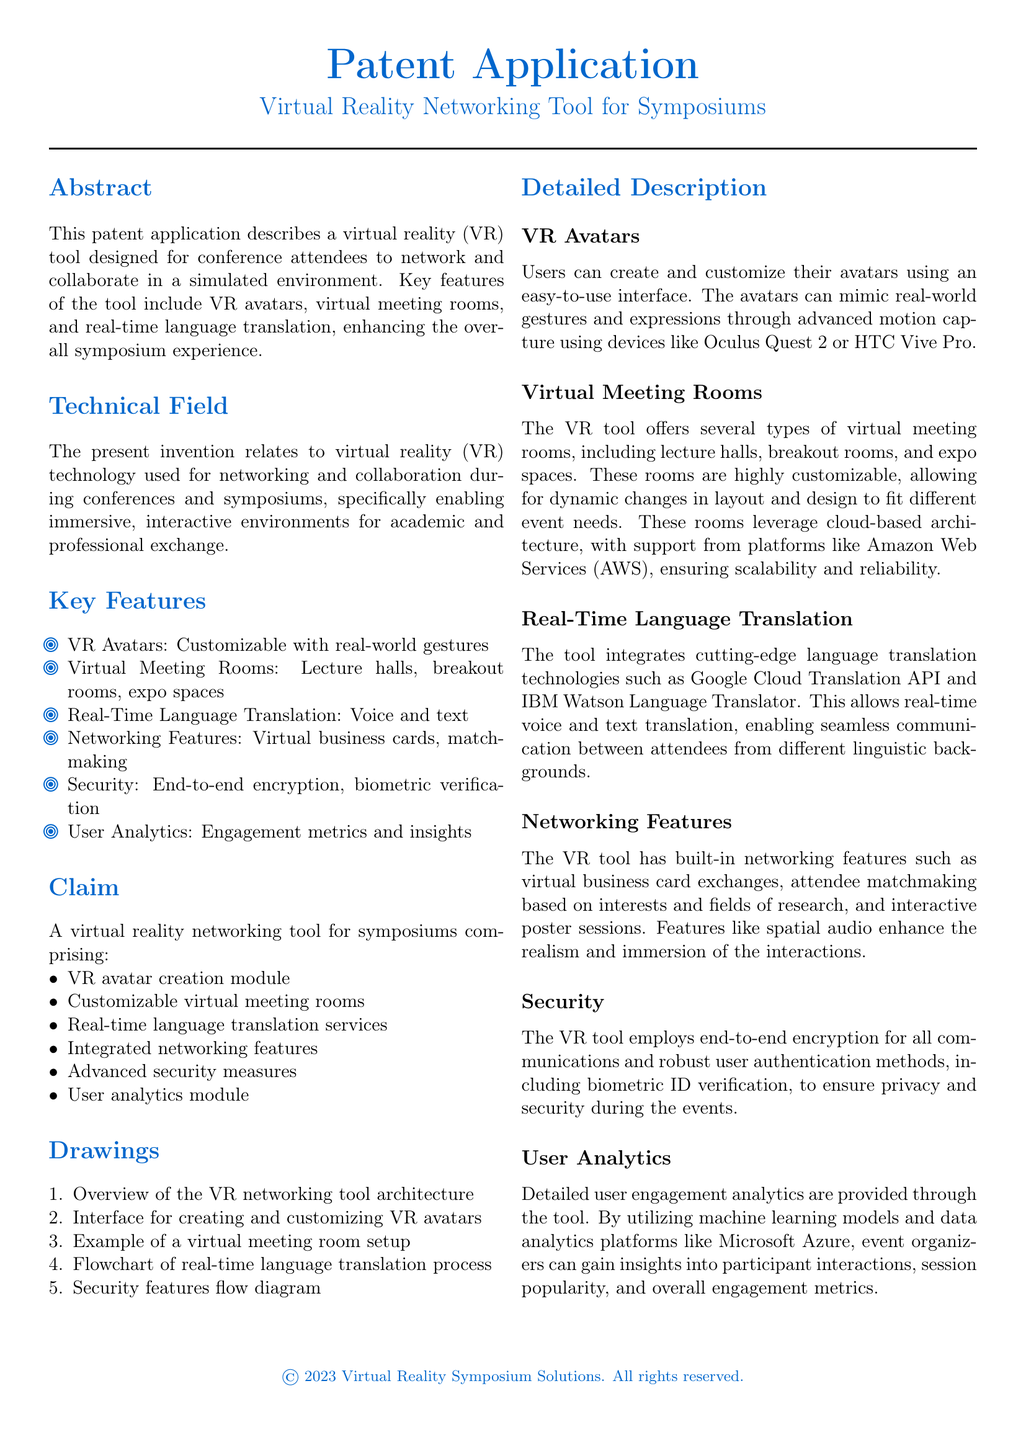What is the title of the patent application? The title is specifically mentioned in the heading of the document.
Answer: Virtual Reality Networking Tool for Symposiums What are the main customizable features of the VR tool? The document lists specific features under the Key Features section.
Answer: VR Avatars, Virtual Meeting Rooms, Real-Time Language Translation How many types of virtual meeting rooms are mentioned? The detailed description provides specific types listed under Virtual Meeting Rooms.
Answer: Three Which technological services are integrated for real-time language translation? The document references specific technologies in the Real-Time Language Translation section.
Answer: Google Cloud Translation API and IBM Watson Language Translator What advanced security method is mentioned in the document? The security section mentions specific verification methods.
Answer: Biometric verification What user engagement analytics platform is mentioned in the patent application? The detailed description specifies the analytics platform used.
Answer: Microsoft Azure What is one of the networking features included in the VR tool? The document lists networking features under Networking Features.
Answer: Virtual business cards What is the main technical field of the invention? The Technical Field section provides a clear statement about the invention's area.
Answer: Virtual reality technology for networking and collaboration 